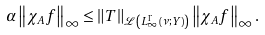Convert formula to latex. <formula><loc_0><loc_0><loc_500><loc_500>\alpha \left \| \chi _ { A } f \right \| _ { \infty } \leq \left \| T \right \| _ { \mathcal { L } \left ( L _ { \infty } ^ { \Gamma } \left ( \nu ; Y \right ) \right ) } \left \| \chi _ { A } f \right \| _ { \infty } .</formula> 